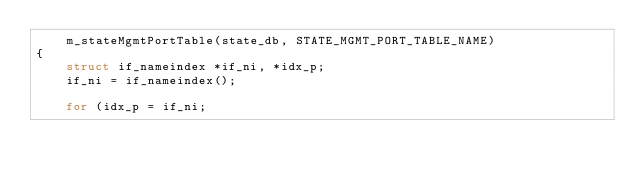Convert code to text. <code><loc_0><loc_0><loc_500><loc_500><_C++_>    m_stateMgmtPortTable(state_db, STATE_MGMT_PORT_TABLE_NAME)
{
    struct if_nameindex *if_ni, *idx_p;
    if_ni = if_nameindex();

    for (idx_p = if_ni;</code> 